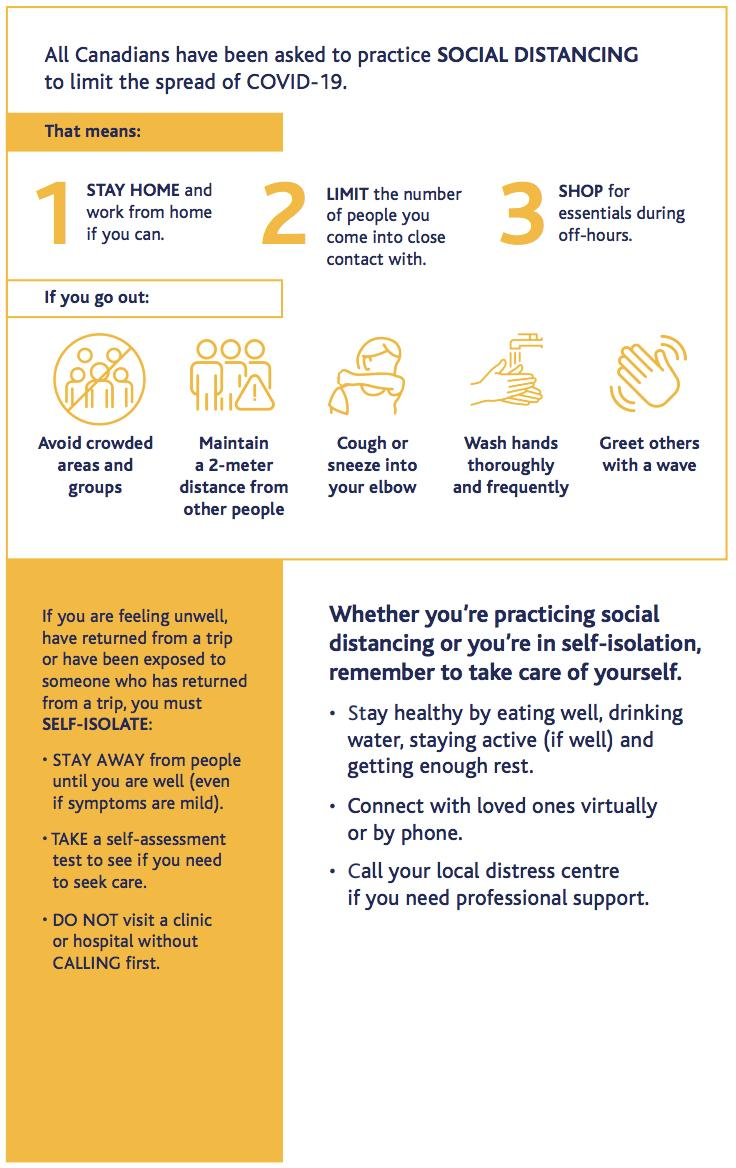Identify some key points in this picture. The best time to shop is during off-hours. It is necessary to follow a total of 3 steps to self-isolate. We should seek professional assistance from the local distress center. We should cough or sneeze into our elbow to prevent the spread of germs. It is recommended to greet others with a wave, as this is a polite and friendly gesture that shows respect and consideration for the other person. 